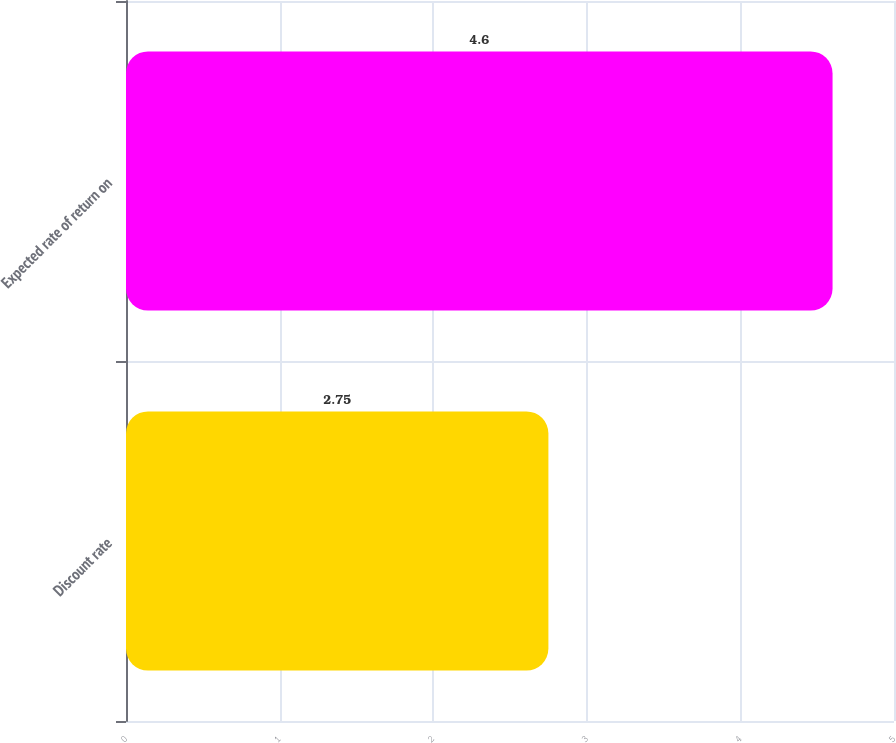Convert chart to OTSL. <chart><loc_0><loc_0><loc_500><loc_500><bar_chart><fcel>Discount rate<fcel>Expected rate of return on<nl><fcel>2.75<fcel>4.6<nl></chart> 